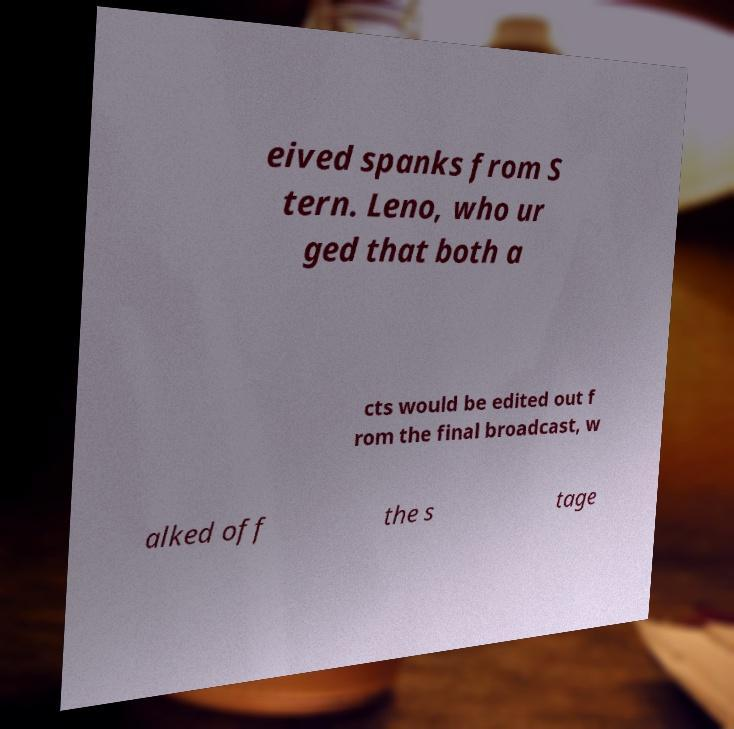Could you extract and type out the text from this image? eived spanks from S tern. Leno, who ur ged that both a cts would be edited out f rom the final broadcast, w alked off the s tage 